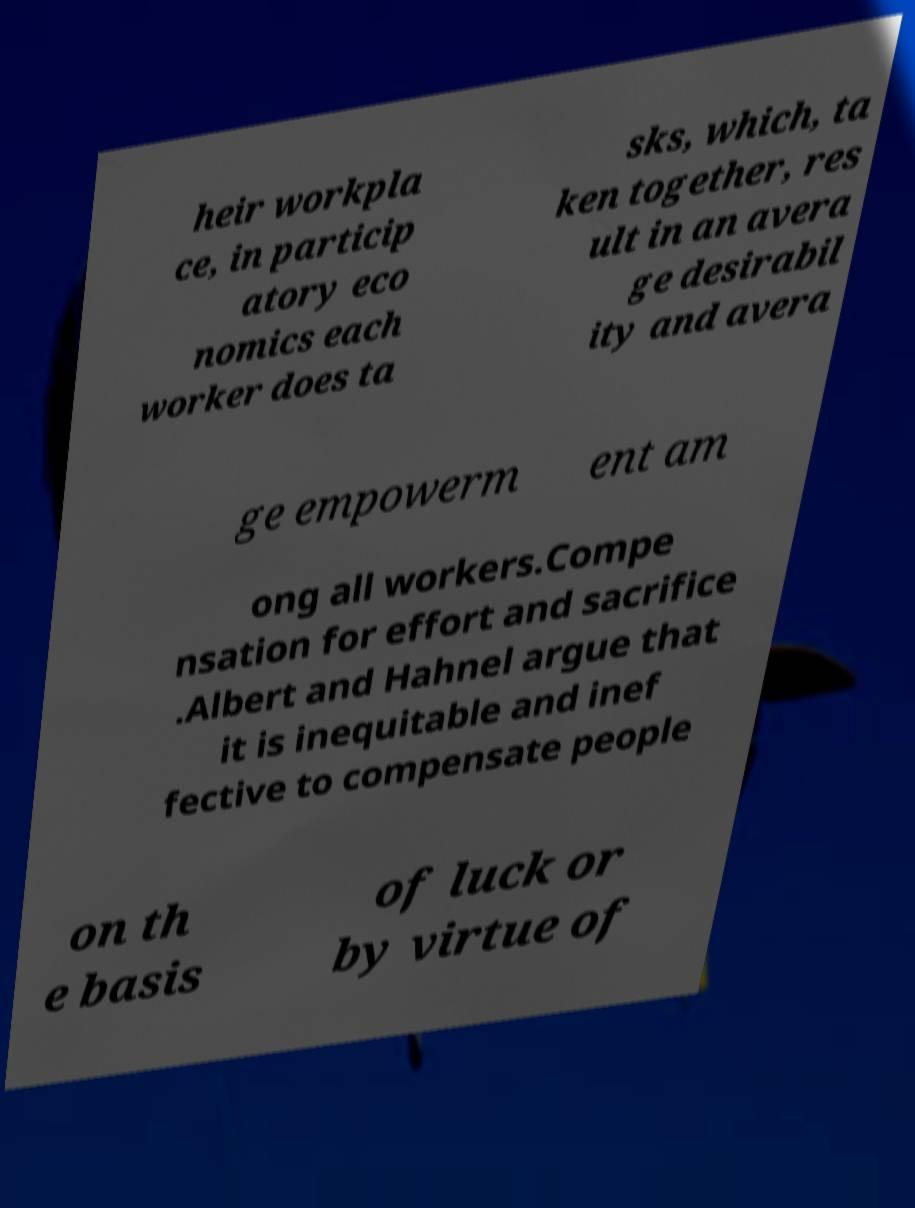Please identify and transcribe the text found in this image. heir workpla ce, in particip atory eco nomics each worker does ta sks, which, ta ken together, res ult in an avera ge desirabil ity and avera ge empowerm ent am ong all workers.Compe nsation for effort and sacrifice .Albert and Hahnel argue that it is inequitable and inef fective to compensate people on th e basis of luck or by virtue of 